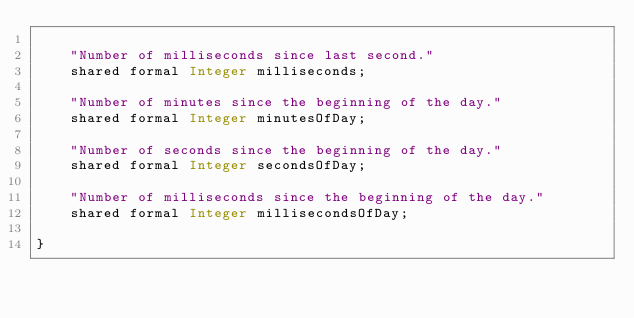Convert code to text. <code><loc_0><loc_0><loc_500><loc_500><_Ceylon_>
    "Number of milliseconds since last second."
    shared formal Integer milliseconds;

    "Number of minutes since the beginning of the day."
    shared formal Integer minutesOfDay;

    "Number of seconds since the beginning of the day."
    shared formal Integer secondsOfDay;

    "Number of milliseconds since the beginning of the day."
    shared formal Integer millisecondsOfDay;

}
</code> 